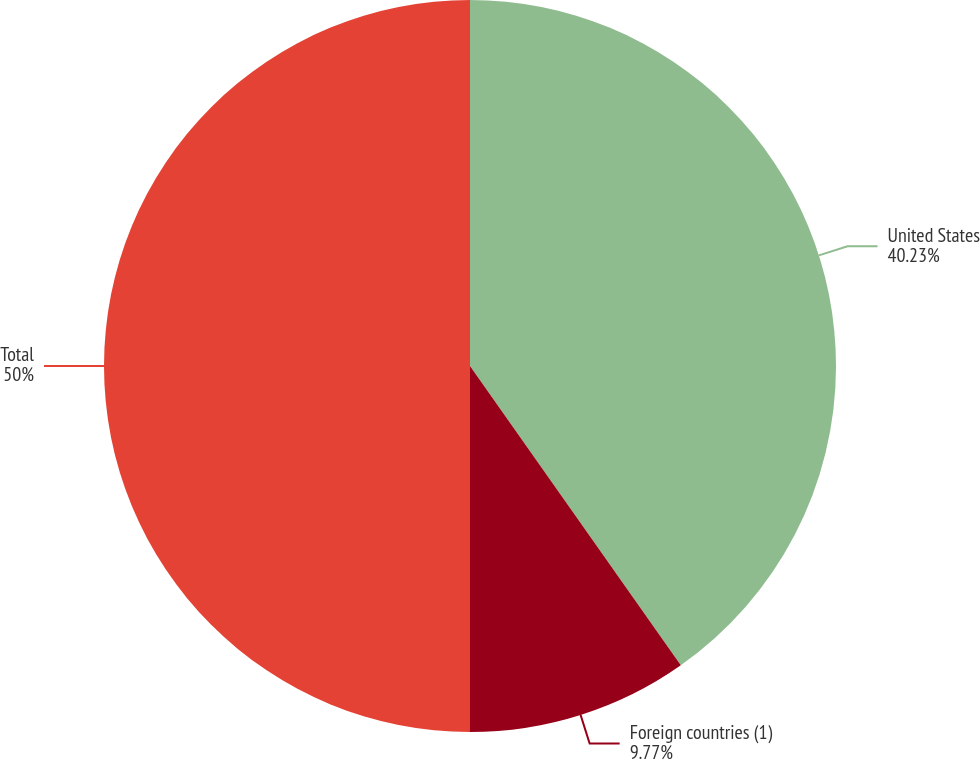Convert chart to OTSL. <chart><loc_0><loc_0><loc_500><loc_500><pie_chart><fcel>United States<fcel>Foreign countries (1)<fcel>Total<nl><fcel>40.23%<fcel>9.77%<fcel>50.0%<nl></chart> 